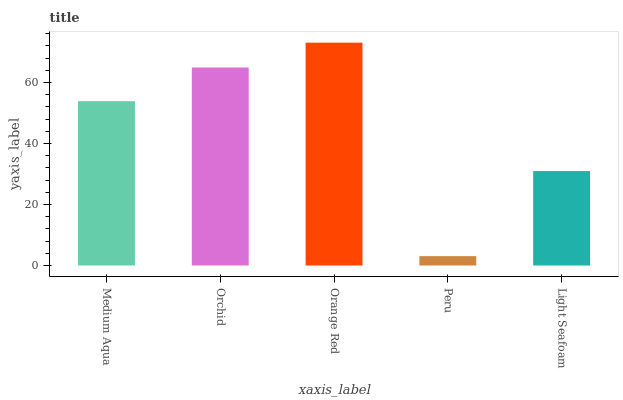Is Orchid the minimum?
Answer yes or no. No. Is Orchid the maximum?
Answer yes or no. No. Is Orchid greater than Medium Aqua?
Answer yes or no. Yes. Is Medium Aqua less than Orchid?
Answer yes or no. Yes. Is Medium Aqua greater than Orchid?
Answer yes or no. No. Is Orchid less than Medium Aqua?
Answer yes or no. No. Is Medium Aqua the high median?
Answer yes or no. Yes. Is Medium Aqua the low median?
Answer yes or no. Yes. Is Orange Red the high median?
Answer yes or no. No. Is Peru the low median?
Answer yes or no. No. 